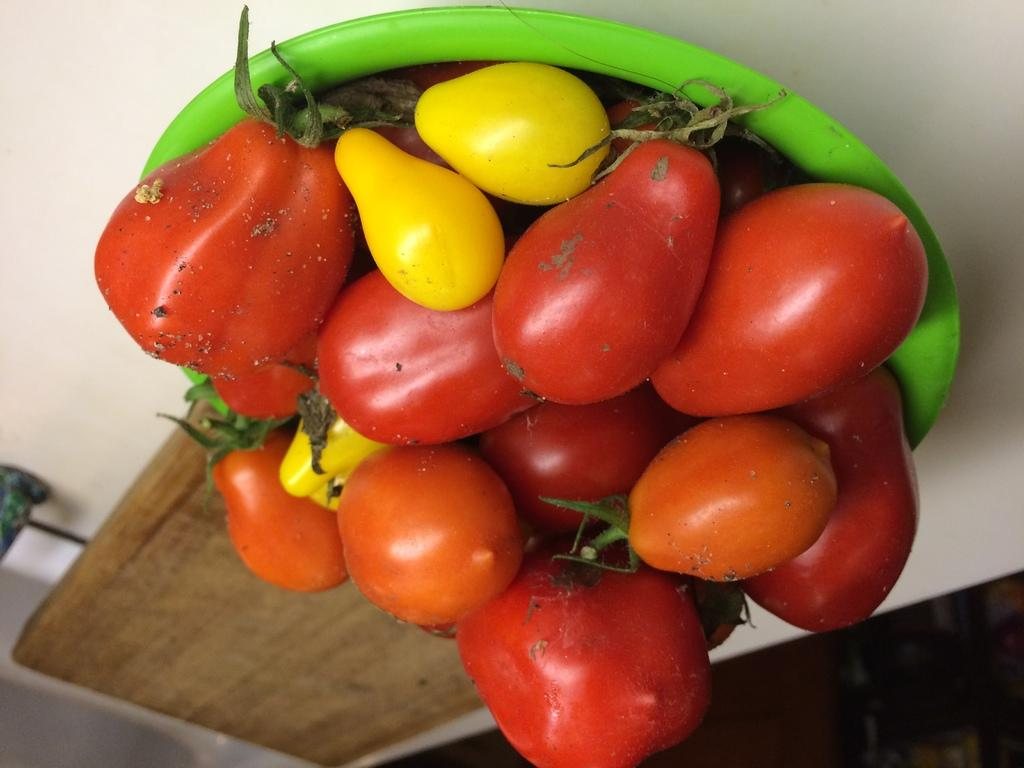What is the main piece of furniture in the image? There is a table in the image. What is placed on the table? There is a bowl containing tomatoes on the table. What colors are the tomatoes? The tomatoes are in red and yellow colors. What else can be seen on the table? There is a tray placed on the table. What type of story is being told by the tomatoes in the image? There is no story being told by the tomatoes in the image; they are simply fruits in a bowl. 